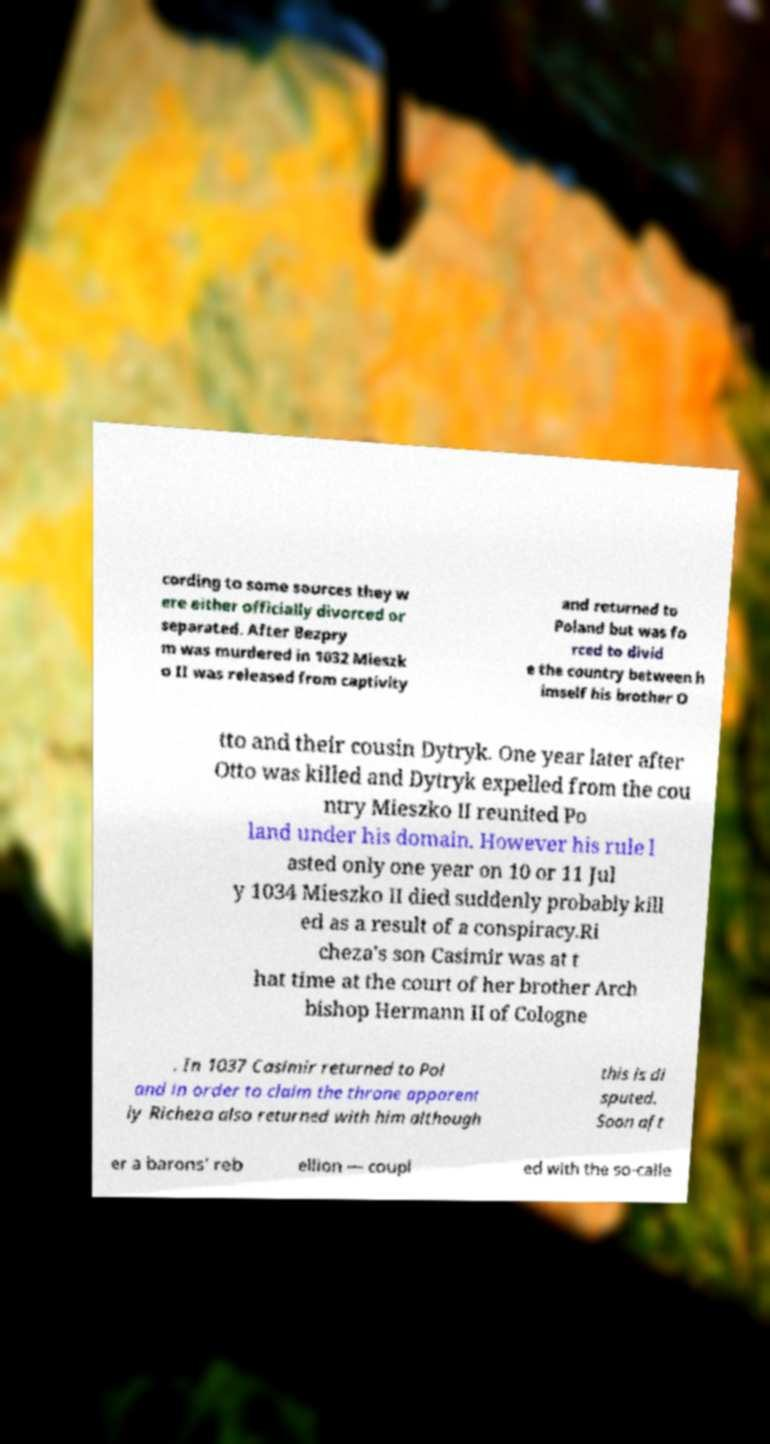Please identify and transcribe the text found in this image. cording to some sources they w ere either officially divorced or separated. After Bezpry m was murdered in 1032 Mieszk o II was released from captivity and returned to Poland but was fo rced to divid e the country between h imself his brother O tto and their cousin Dytryk. One year later after Otto was killed and Dytryk expelled from the cou ntry Mieszko II reunited Po land under his domain. However his rule l asted only one year on 10 or 11 Jul y 1034 Mieszko II died suddenly probably kill ed as a result of a conspiracy.Ri cheza's son Casimir was at t hat time at the court of her brother Arch bishop Hermann II of Cologne . In 1037 Casimir returned to Pol and in order to claim the throne apparent ly Richeza also returned with him although this is di sputed. Soon aft er a barons' reb ellion — coupl ed with the so-calle 